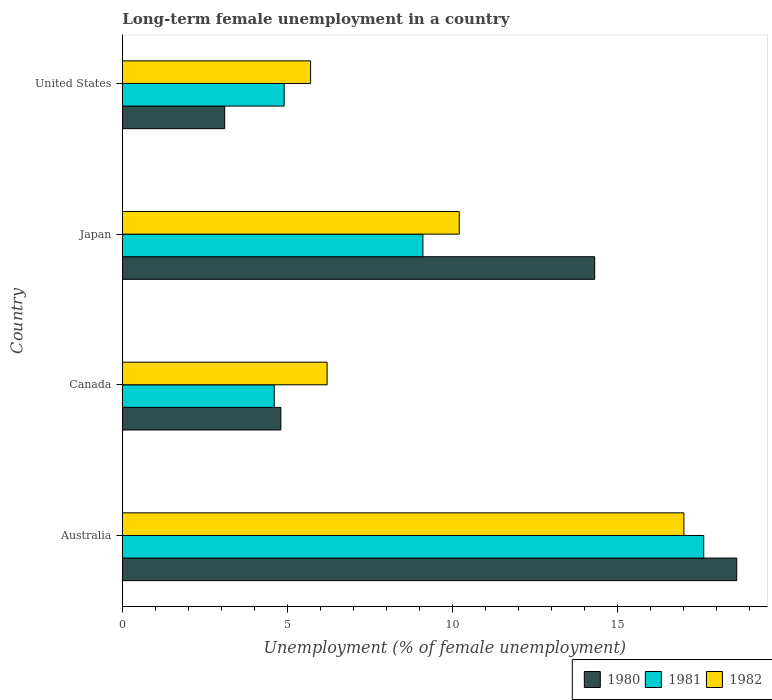How many groups of bars are there?
Make the answer very short. 4. Are the number of bars on each tick of the Y-axis equal?
Keep it short and to the point. Yes. How many bars are there on the 3rd tick from the top?
Ensure brevity in your answer.  3. What is the label of the 3rd group of bars from the top?
Offer a very short reply. Canada. In how many cases, is the number of bars for a given country not equal to the number of legend labels?
Your answer should be very brief. 0. What is the percentage of long-term unemployed female population in 1982 in Australia?
Ensure brevity in your answer.  17. Across all countries, what is the maximum percentage of long-term unemployed female population in 1980?
Your answer should be compact. 18.6. Across all countries, what is the minimum percentage of long-term unemployed female population in 1982?
Offer a very short reply. 5.7. In which country was the percentage of long-term unemployed female population in 1982 maximum?
Make the answer very short. Australia. In which country was the percentage of long-term unemployed female population in 1982 minimum?
Your answer should be very brief. United States. What is the total percentage of long-term unemployed female population in 1980 in the graph?
Your answer should be very brief. 40.8. What is the difference between the percentage of long-term unemployed female population in 1980 in Canada and that in United States?
Your answer should be very brief. 1.7. What is the difference between the percentage of long-term unemployed female population in 1980 in Canada and the percentage of long-term unemployed female population in 1981 in Australia?
Your response must be concise. -12.8. What is the average percentage of long-term unemployed female population in 1981 per country?
Offer a very short reply. 9.05. What is the difference between the percentage of long-term unemployed female population in 1980 and percentage of long-term unemployed female population in 1982 in Australia?
Your answer should be very brief. 1.6. In how many countries, is the percentage of long-term unemployed female population in 1980 greater than 7 %?
Keep it short and to the point. 2. What is the ratio of the percentage of long-term unemployed female population in 1982 in Canada to that in United States?
Your answer should be compact. 1.09. Is the percentage of long-term unemployed female population in 1982 in Australia less than that in Canada?
Make the answer very short. No. Is the difference between the percentage of long-term unemployed female population in 1980 in Australia and Canada greater than the difference between the percentage of long-term unemployed female population in 1982 in Australia and Canada?
Provide a succinct answer. Yes. What is the difference between the highest and the second highest percentage of long-term unemployed female population in 1981?
Your answer should be compact. 8.5. What is the difference between the highest and the lowest percentage of long-term unemployed female population in 1980?
Your answer should be very brief. 15.5. In how many countries, is the percentage of long-term unemployed female population in 1981 greater than the average percentage of long-term unemployed female population in 1981 taken over all countries?
Your answer should be very brief. 2. What does the 3rd bar from the bottom in Japan represents?
Your response must be concise. 1982. Is it the case that in every country, the sum of the percentage of long-term unemployed female population in 1980 and percentage of long-term unemployed female population in 1981 is greater than the percentage of long-term unemployed female population in 1982?
Keep it short and to the point. Yes. Where does the legend appear in the graph?
Ensure brevity in your answer.  Bottom right. How many legend labels are there?
Offer a terse response. 3. How are the legend labels stacked?
Provide a short and direct response. Horizontal. What is the title of the graph?
Provide a short and direct response. Long-term female unemployment in a country. What is the label or title of the X-axis?
Provide a succinct answer. Unemployment (% of female unemployment). What is the label or title of the Y-axis?
Your answer should be compact. Country. What is the Unemployment (% of female unemployment) of 1980 in Australia?
Your answer should be very brief. 18.6. What is the Unemployment (% of female unemployment) in 1981 in Australia?
Your answer should be very brief. 17.6. What is the Unemployment (% of female unemployment) of 1980 in Canada?
Keep it short and to the point. 4.8. What is the Unemployment (% of female unemployment) in 1981 in Canada?
Offer a very short reply. 4.6. What is the Unemployment (% of female unemployment) in 1982 in Canada?
Your response must be concise. 6.2. What is the Unemployment (% of female unemployment) in 1980 in Japan?
Provide a succinct answer. 14.3. What is the Unemployment (% of female unemployment) of 1981 in Japan?
Provide a short and direct response. 9.1. What is the Unemployment (% of female unemployment) in 1982 in Japan?
Provide a short and direct response. 10.2. What is the Unemployment (% of female unemployment) in 1980 in United States?
Provide a short and direct response. 3.1. What is the Unemployment (% of female unemployment) in 1981 in United States?
Your answer should be compact. 4.9. What is the Unemployment (% of female unemployment) of 1982 in United States?
Your response must be concise. 5.7. Across all countries, what is the maximum Unemployment (% of female unemployment) of 1980?
Provide a short and direct response. 18.6. Across all countries, what is the maximum Unemployment (% of female unemployment) of 1981?
Provide a short and direct response. 17.6. Across all countries, what is the maximum Unemployment (% of female unemployment) of 1982?
Your response must be concise. 17. Across all countries, what is the minimum Unemployment (% of female unemployment) of 1980?
Provide a short and direct response. 3.1. Across all countries, what is the minimum Unemployment (% of female unemployment) in 1981?
Keep it short and to the point. 4.6. Across all countries, what is the minimum Unemployment (% of female unemployment) in 1982?
Offer a very short reply. 5.7. What is the total Unemployment (% of female unemployment) in 1980 in the graph?
Keep it short and to the point. 40.8. What is the total Unemployment (% of female unemployment) of 1981 in the graph?
Offer a very short reply. 36.2. What is the total Unemployment (% of female unemployment) of 1982 in the graph?
Keep it short and to the point. 39.1. What is the difference between the Unemployment (% of female unemployment) in 1981 in Australia and that in Canada?
Provide a succinct answer. 13. What is the difference between the Unemployment (% of female unemployment) of 1980 in Australia and that in Japan?
Offer a terse response. 4.3. What is the difference between the Unemployment (% of female unemployment) of 1981 in Australia and that in Japan?
Make the answer very short. 8.5. What is the difference between the Unemployment (% of female unemployment) of 1982 in Australia and that in Japan?
Your answer should be very brief. 6.8. What is the difference between the Unemployment (% of female unemployment) of 1981 in Australia and that in United States?
Ensure brevity in your answer.  12.7. What is the difference between the Unemployment (% of female unemployment) in 1982 in Australia and that in United States?
Provide a succinct answer. 11.3. What is the difference between the Unemployment (% of female unemployment) of 1982 in Canada and that in Japan?
Your answer should be very brief. -4. What is the difference between the Unemployment (% of female unemployment) in 1982 in Canada and that in United States?
Keep it short and to the point. 0.5. What is the difference between the Unemployment (% of female unemployment) in 1980 in Japan and that in United States?
Ensure brevity in your answer.  11.2. What is the difference between the Unemployment (% of female unemployment) in 1981 in Japan and that in United States?
Your answer should be very brief. 4.2. What is the difference between the Unemployment (% of female unemployment) of 1980 in Australia and the Unemployment (% of female unemployment) of 1981 in Canada?
Provide a short and direct response. 14. What is the difference between the Unemployment (% of female unemployment) in 1980 in Australia and the Unemployment (% of female unemployment) in 1982 in Canada?
Ensure brevity in your answer.  12.4. What is the difference between the Unemployment (% of female unemployment) of 1981 in Australia and the Unemployment (% of female unemployment) of 1982 in Canada?
Your answer should be compact. 11.4. What is the difference between the Unemployment (% of female unemployment) of 1980 in Australia and the Unemployment (% of female unemployment) of 1981 in Japan?
Your answer should be very brief. 9.5. What is the difference between the Unemployment (% of female unemployment) of 1981 in Australia and the Unemployment (% of female unemployment) of 1982 in Japan?
Give a very brief answer. 7.4. What is the difference between the Unemployment (% of female unemployment) of 1980 in Australia and the Unemployment (% of female unemployment) of 1981 in United States?
Your answer should be compact. 13.7. What is the difference between the Unemployment (% of female unemployment) of 1980 in Canada and the Unemployment (% of female unemployment) of 1981 in Japan?
Offer a terse response. -4.3. What is the difference between the Unemployment (% of female unemployment) in 1980 in Canada and the Unemployment (% of female unemployment) in 1982 in Japan?
Keep it short and to the point. -5.4. What is the difference between the Unemployment (% of female unemployment) of 1981 in Canada and the Unemployment (% of female unemployment) of 1982 in Japan?
Your answer should be very brief. -5.6. What is the difference between the Unemployment (% of female unemployment) in 1980 in Canada and the Unemployment (% of female unemployment) in 1982 in United States?
Ensure brevity in your answer.  -0.9. What is the difference between the Unemployment (% of female unemployment) in 1980 in Japan and the Unemployment (% of female unemployment) in 1981 in United States?
Your response must be concise. 9.4. What is the difference between the Unemployment (% of female unemployment) in 1981 in Japan and the Unemployment (% of female unemployment) in 1982 in United States?
Give a very brief answer. 3.4. What is the average Unemployment (% of female unemployment) of 1980 per country?
Provide a succinct answer. 10.2. What is the average Unemployment (% of female unemployment) in 1981 per country?
Provide a succinct answer. 9.05. What is the average Unemployment (% of female unemployment) in 1982 per country?
Your answer should be very brief. 9.78. What is the difference between the Unemployment (% of female unemployment) in 1980 and Unemployment (% of female unemployment) in 1981 in Australia?
Offer a terse response. 1. What is the difference between the Unemployment (% of female unemployment) of 1981 and Unemployment (% of female unemployment) of 1982 in Australia?
Make the answer very short. 0.6. What is the difference between the Unemployment (% of female unemployment) in 1980 and Unemployment (% of female unemployment) in 1981 in Canada?
Ensure brevity in your answer.  0.2. What is the difference between the Unemployment (% of female unemployment) of 1981 and Unemployment (% of female unemployment) of 1982 in Canada?
Provide a short and direct response. -1.6. What is the difference between the Unemployment (% of female unemployment) in 1980 and Unemployment (% of female unemployment) in 1981 in Japan?
Provide a short and direct response. 5.2. What is the difference between the Unemployment (% of female unemployment) of 1980 and Unemployment (% of female unemployment) of 1982 in Japan?
Offer a very short reply. 4.1. What is the difference between the Unemployment (% of female unemployment) of 1981 and Unemployment (% of female unemployment) of 1982 in United States?
Make the answer very short. -0.8. What is the ratio of the Unemployment (% of female unemployment) of 1980 in Australia to that in Canada?
Make the answer very short. 3.88. What is the ratio of the Unemployment (% of female unemployment) of 1981 in Australia to that in Canada?
Your answer should be compact. 3.83. What is the ratio of the Unemployment (% of female unemployment) in 1982 in Australia to that in Canada?
Ensure brevity in your answer.  2.74. What is the ratio of the Unemployment (% of female unemployment) of 1980 in Australia to that in Japan?
Keep it short and to the point. 1.3. What is the ratio of the Unemployment (% of female unemployment) of 1981 in Australia to that in Japan?
Ensure brevity in your answer.  1.93. What is the ratio of the Unemployment (% of female unemployment) of 1982 in Australia to that in Japan?
Give a very brief answer. 1.67. What is the ratio of the Unemployment (% of female unemployment) in 1981 in Australia to that in United States?
Your response must be concise. 3.59. What is the ratio of the Unemployment (% of female unemployment) in 1982 in Australia to that in United States?
Make the answer very short. 2.98. What is the ratio of the Unemployment (% of female unemployment) of 1980 in Canada to that in Japan?
Keep it short and to the point. 0.34. What is the ratio of the Unemployment (% of female unemployment) of 1981 in Canada to that in Japan?
Ensure brevity in your answer.  0.51. What is the ratio of the Unemployment (% of female unemployment) in 1982 in Canada to that in Japan?
Give a very brief answer. 0.61. What is the ratio of the Unemployment (% of female unemployment) of 1980 in Canada to that in United States?
Keep it short and to the point. 1.55. What is the ratio of the Unemployment (% of female unemployment) of 1981 in Canada to that in United States?
Give a very brief answer. 0.94. What is the ratio of the Unemployment (% of female unemployment) in 1982 in Canada to that in United States?
Your response must be concise. 1.09. What is the ratio of the Unemployment (% of female unemployment) in 1980 in Japan to that in United States?
Your response must be concise. 4.61. What is the ratio of the Unemployment (% of female unemployment) in 1981 in Japan to that in United States?
Provide a short and direct response. 1.86. What is the ratio of the Unemployment (% of female unemployment) of 1982 in Japan to that in United States?
Offer a terse response. 1.79. What is the difference between the highest and the second highest Unemployment (% of female unemployment) of 1980?
Your answer should be very brief. 4.3. What is the difference between the highest and the second highest Unemployment (% of female unemployment) of 1981?
Your answer should be very brief. 8.5. What is the difference between the highest and the lowest Unemployment (% of female unemployment) in 1980?
Your answer should be compact. 15.5. 